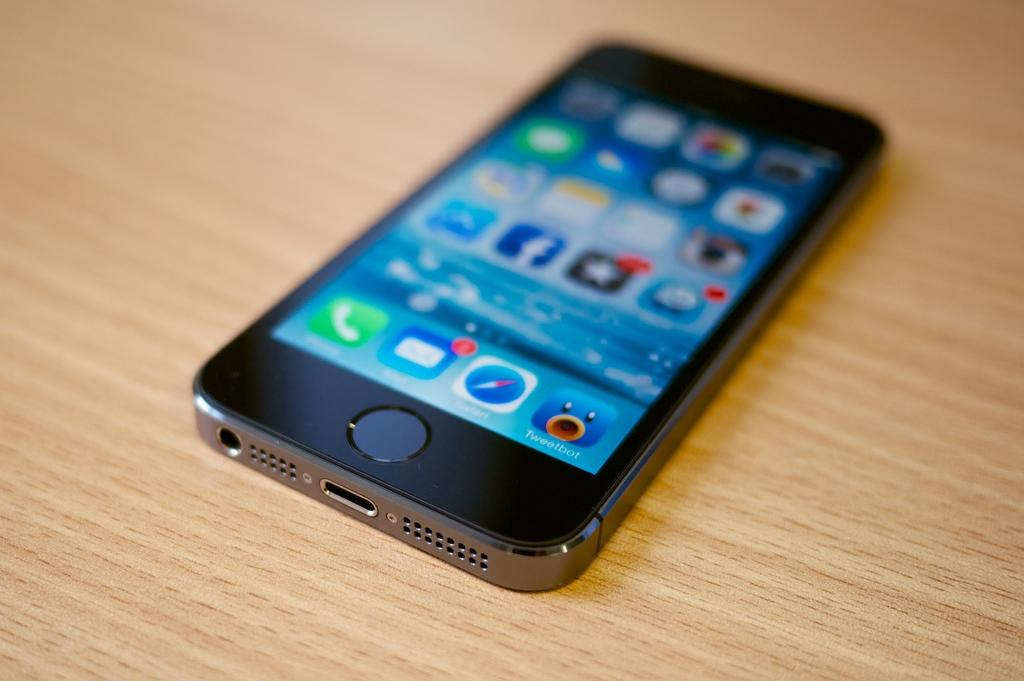<image>
Offer a succinct explanation of the picture presented. A cell phone on a table that has a Tweetbot app installed. 